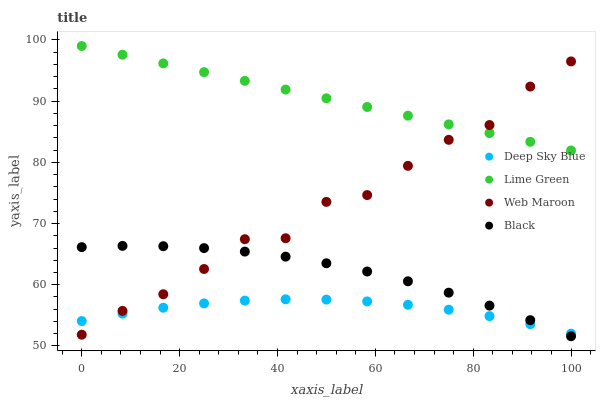Does Deep Sky Blue have the minimum area under the curve?
Answer yes or no. Yes. Does Lime Green have the maximum area under the curve?
Answer yes or no. Yes. Does Lime Green have the minimum area under the curve?
Answer yes or no. No. Does Deep Sky Blue have the maximum area under the curve?
Answer yes or no. No. Is Lime Green the smoothest?
Answer yes or no. Yes. Is Web Maroon the roughest?
Answer yes or no. Yes. Is Deep Sky Blue the smoothest?
Answer yes or no. No. Is Deep Sky Blue the roughest?
Answer yes or no. No. Does Black have the lowest value?
Answer yes or no. Yes. Does Deep Sky Blue have the lowest value?
Answer yes or no. No. Does Lime Green have the highest value?
Answer yes or no. Yes. Does Deep Sky Blue have the highest value?
Answer yes or no. No. Is Black less than Lime Green?
Answer yes or no. Yes. Is Lime Green greater than Deep Sky Blue?
Answer yes or no. Yes. Does Web Maroon intersect Lime Green?
Answer yes or no. Yes. Is Web Maroon less than Lime Green?
Answer yes or no. No. Is Web Maroon greater than Lime Green?
Answer yes or no. No. Does Black intersect Lime Green?
Answer yes or no. No. 